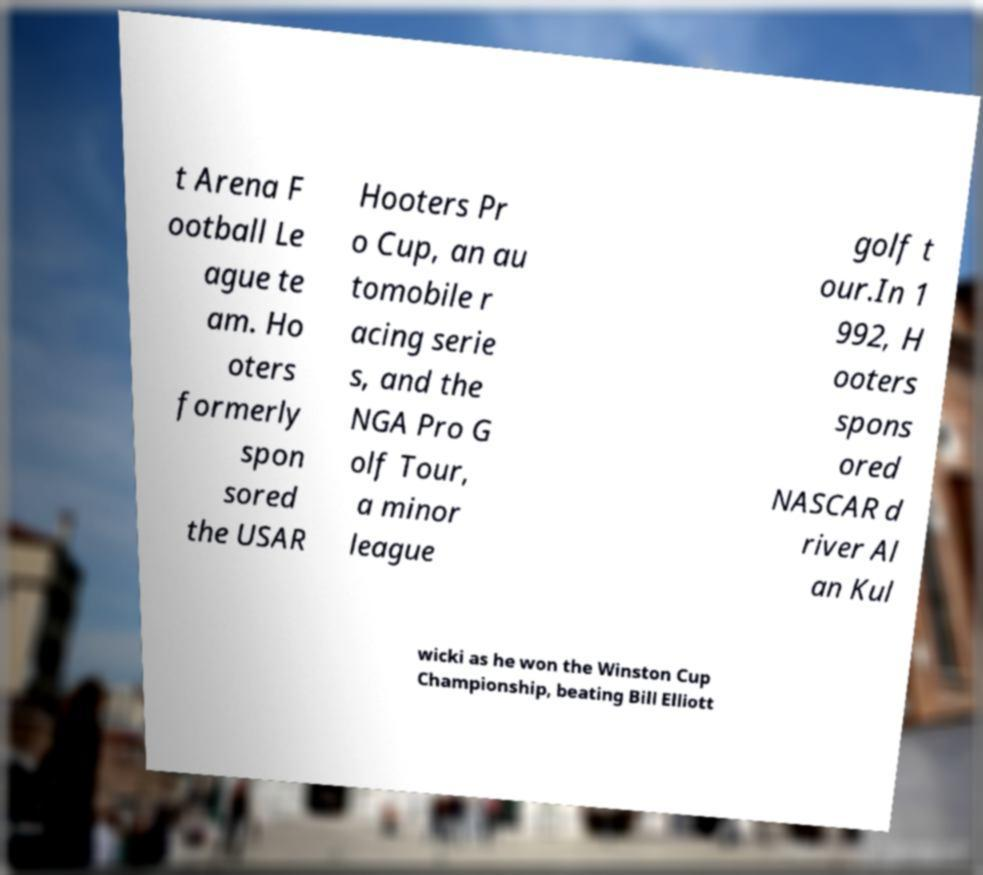What messages or text are displayed in this image? I need them in a readable, typed format. t Arena F ootball Le ague te am. Ho oters formerly spon sored the USAR Hooters Pr o Cup, an au tomobile r acing serie s, and the NGA Pro G olf Tour, a minor league golf t our.In 1 992, H ooters spons ored NASCAR d river Al an Kul wicki as he won the Winston Cup Championship, beating Bill Elliott 